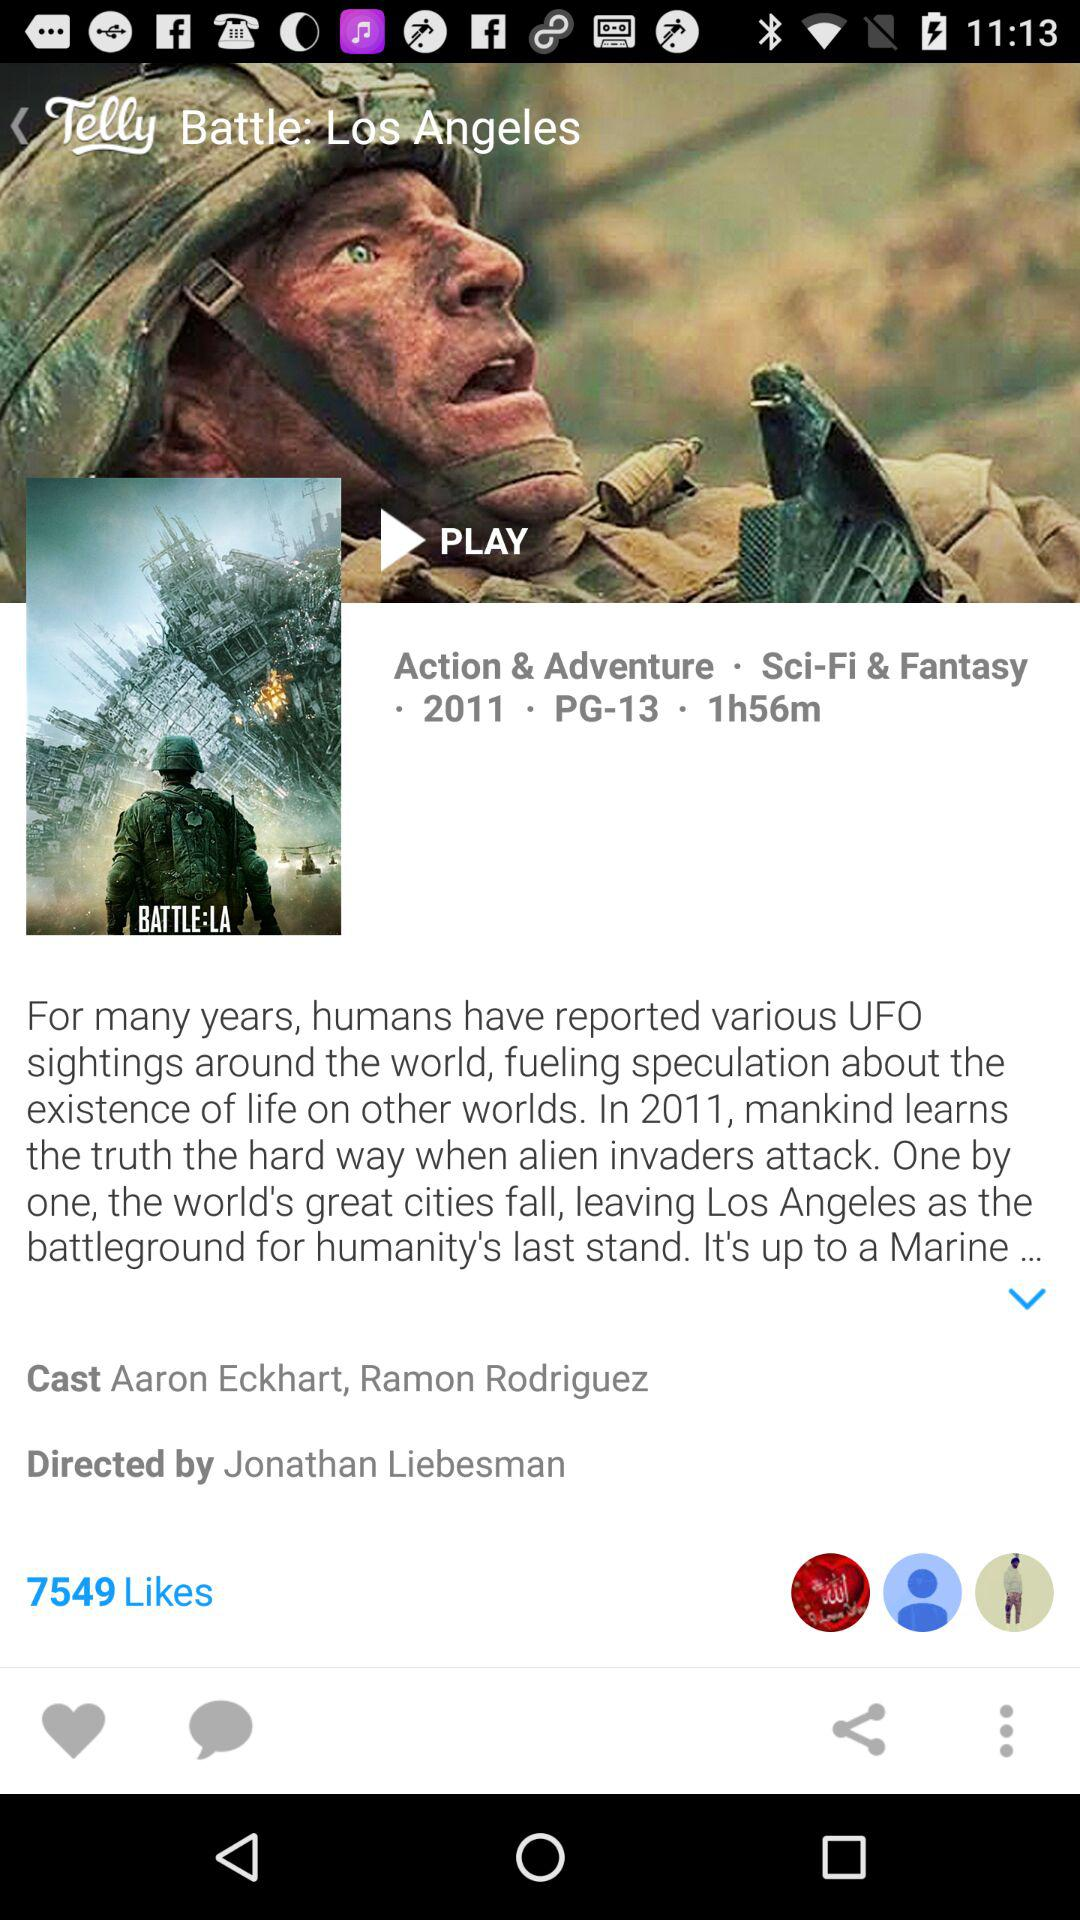How many likes are there for this movie? There are 7549 likes. 